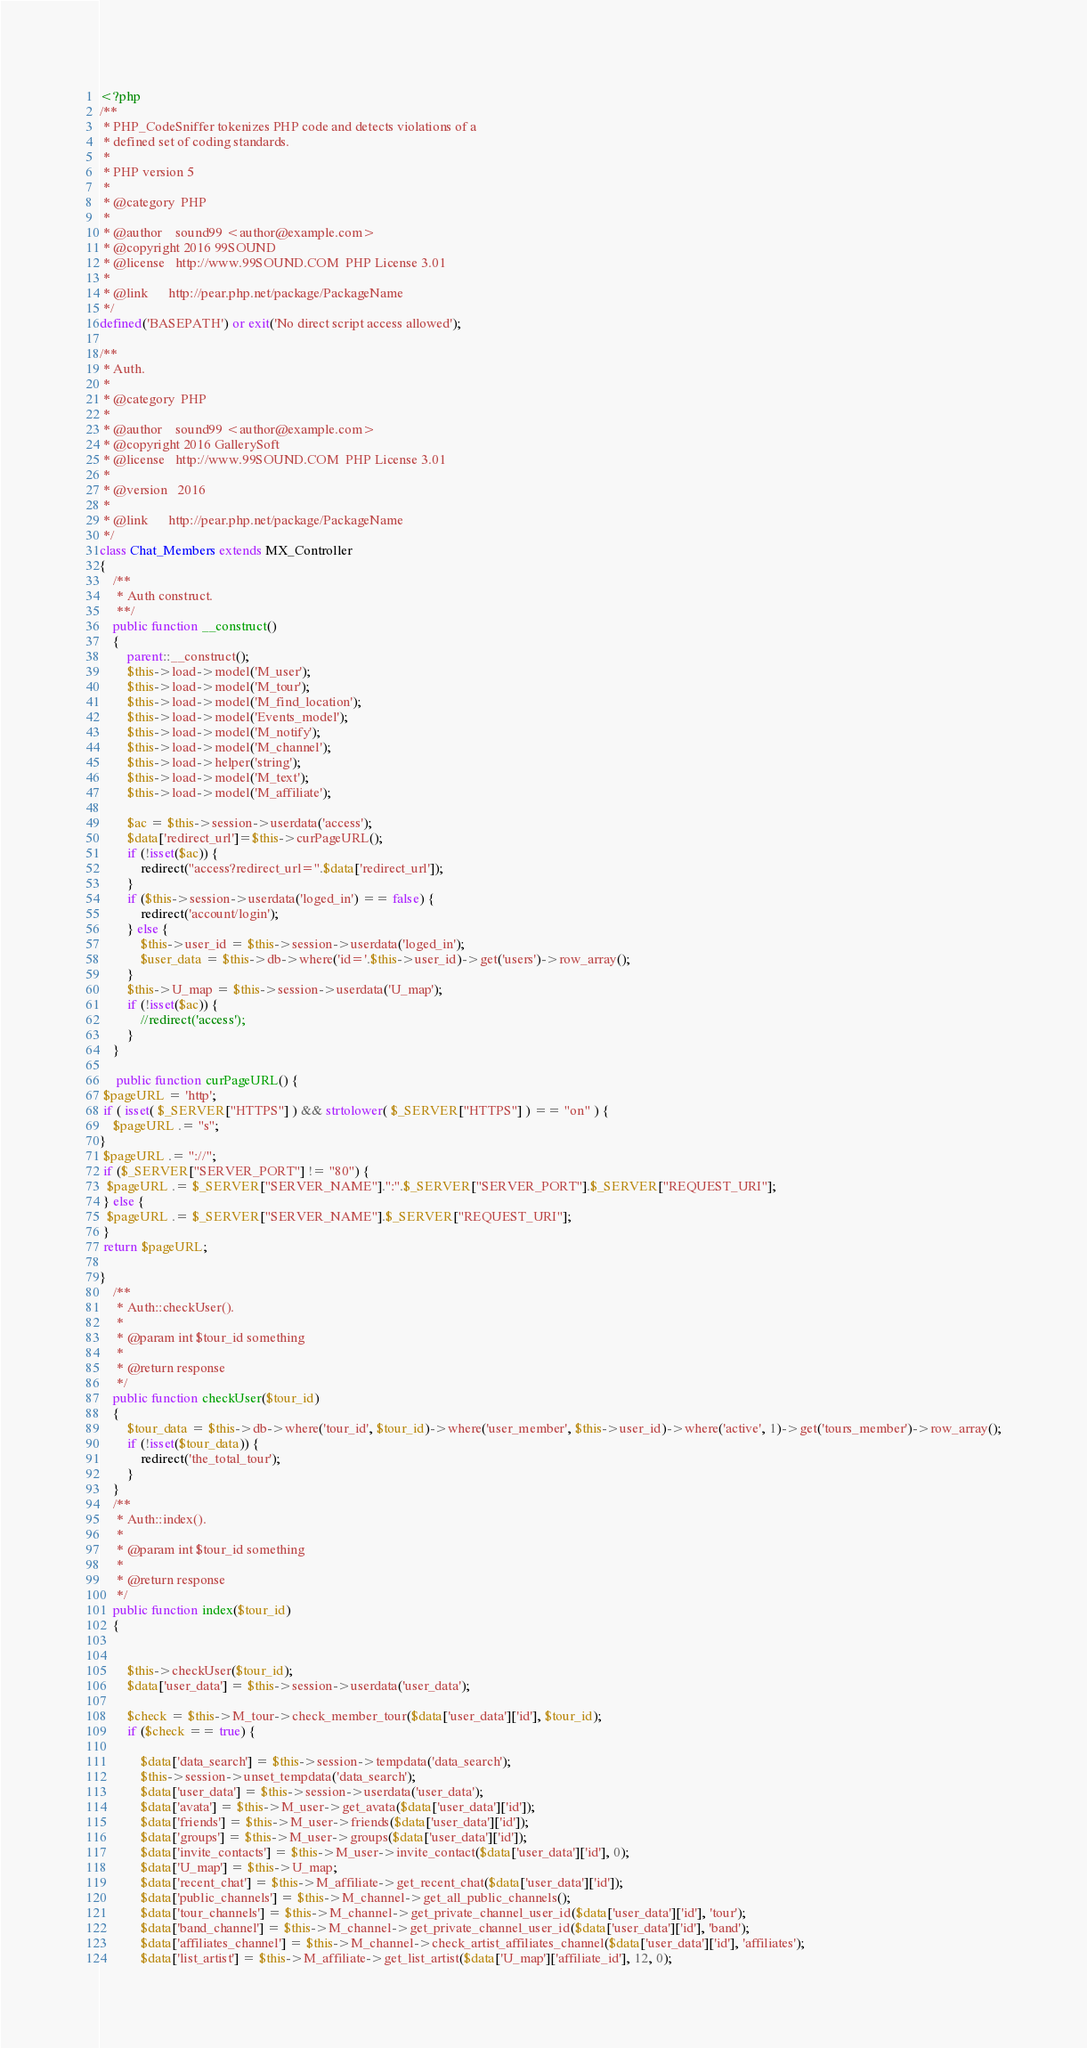Convert code to text. <code><loc_0><loc_0><loc_500><loc_500><_PHP_><?php
/**
 * PHP_CodeSniffer tokenizes PHP code and detects violations of a
 * defined set of coding standards.
 *
 * PHP version 5
 *
 * @category  PHP
 *
 * @author    sound99 <author@example.com>
 * @copyright 2016 99SOUND
 * @license   http://www.99SOUND.COM  PHP License 3.01   
 *
 * @link      http://pear.php.net/package/PackageName
 */
defined('BASEPATH') or exit('No direct script access allowed');

/**
 * Auth.
 * 
 * @category  PHP
 *
 * @author    sound99 <author@example.com>
 * @copyright 2016 GallerySoft
 * @license   http://www.99SOUND.COM  PHP License 3.01
 *
 * @version   2016
 *
 * @link      http://pear.php.net/package/PackageName
 */
class Chat_Members extends MX_Controller
{
    /**
     * Auth construct.
     **/
    public function __construct()
    {
        parent::__construct();
        $this->load->model('M_user');
        $this->load->model('M_tour');
        $this->load->model('M_find_location');
        $this->load->model('Events_model');
        $this->load->model('M_notify');
        $this->load->model('M_channel');
        $this->load->helper('string');
        $this->load->model('M_text');
        $this->load->model('M_affiliate');
        
        $ac = $this->session->userdata('access');
        $data['redirect_url']=$this->curPageURL();
        if (!isset($ac)) {
            redirect("access?redirect_url=".$data['redirect_url']);
        }
        if ($this->session->userdata('loged_in') == false) {
            redirect('account/login');
        } else {
            $this->user_id = $this->session->userdata('loged_in');
            $user_data = $this->db->where('id='.$this->user_id)->get('users')->row_array();
        }
        $this->U_map = $this->session->userdata('U_map');
        if (!isset($ac)) {
            //redirect('access');
        }
    }
    
     public function curPageURL() {
 $pageURL = 'http';
 if ( isset( $_SERVER["HTTPS"] ) && strtolower( $_SERVER["HTTPS"] ) == "on" ) {
    $pageURL .= "s";
}
 $pageURL .= "://";
 if ($_SERVER["SERVER_PORT"] != "80") {
  $pageURL .= $_SERVER["SERVER_NAME"].":".$_SERVER["SERVER_PORT"].$_SERVER["REQUEST_URI"];
 } else {
  $pageURL .= $_SERVER["SERVER_NAME"].$_SERVER["REQUEST_URI"];
 }
 return $pageURL;
 
}
    /**
     * Auth::checkUser().
     * 
     * @param int $tour_id something
     * 
     * @return response
     */
    public function checkUser($tour_id)
    {
        $tour_data = $this->db->where('tour_id', $tour_id)->where('user_member', $this->user_id)->where('active', 1)->get('tours_member')->row_array();
        if (!isset($tour_data)) {
            redirect('the_total_tour');
        }
    }
    /**
     * Auth::index().
     * 
     * @param int $tour_id something
     * 
     * @return response
     */
    public function index($tour_id)
    {
        
       
        $this->checkUser($tour_id);
        $data['user_data'] = $this->session->userdata('user_data');
        
        $check = $this->M_tour->check_member_tour($data['user_data']['id'], $tour_id);
        if ($check == true) {
           
            $data['data_search'] = $this->session->tempdata('data_search');
            $this->session->unset_tempdata('data_search');
            $data['user_data'] = $this->session->userdata('user_data');
            $data['avata'] = $this->M_user->get_avata($data['user_data']['id']);
            $data['friends'] = $this->M_user->friends($data['user_data']['id']);
            $data['groups'] = $this->M_user->groups($data['user_data']['id']);
            $data['invite_contacts'] = $this->M_user->invite_contact($data['user_data']['id'], 0);
            $data['U_map'] = $this->U_map;
            $data['recent_chat'] = $this->M_affiliate->get_recent_chat($data['user_data']['id']);
            $data['public_channels'] = $this->M_channel->get_all_public_channels();
            $data['tour_channels'] = $this->M_channel->get_private_channel_user_id($data['user_data']['id'], 'tour');
            $data['band_channel'] = $this->M_channel->get_private_channel_user_id($data['user_data']['id'], 'band');
            $data['affiliates_channel'] = $this->M_channel->check_artist_affiliates_channel($data['user_data']['id'], 'affiliates');
            $data['list_artist'] = $this->M_affiliate->get_list_artist($data['U_map']['affiliate_id'], 12, 0);</code> 